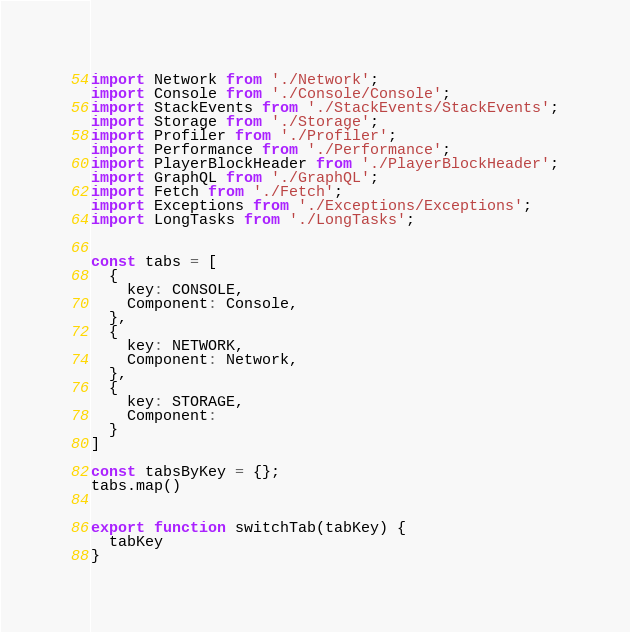<code> <loc_0><loc_0><loc_500><loc_500><_JavaScript_>import Network from './Network';
import Console from './Console/Console';
import StackEvents from './StackEvents/StackEvents';
import Storage from './Storage';
import Profiler from './Profiler';
import Performance from './Performance';
import PlayerBlockHeader from './PlayerBlockHeader';
import GraphQL from './GraphQL';
import Fetch from './Fetch';
import Exceptions from './Exceptions/Exceptions';
import LongTasks from './LongTasks';


const tabs = [
  {
    key: CONSOLE,
    Component: Console,
  },
  {
    key: NETWORK,
    Component: Network,
  },
  {
    key: STORAGE,
    Component: 
  }
]

const tabsByKey = {};
tabs.map()


export function switchTab(tabKey) {
  tabKey
}


</code> 